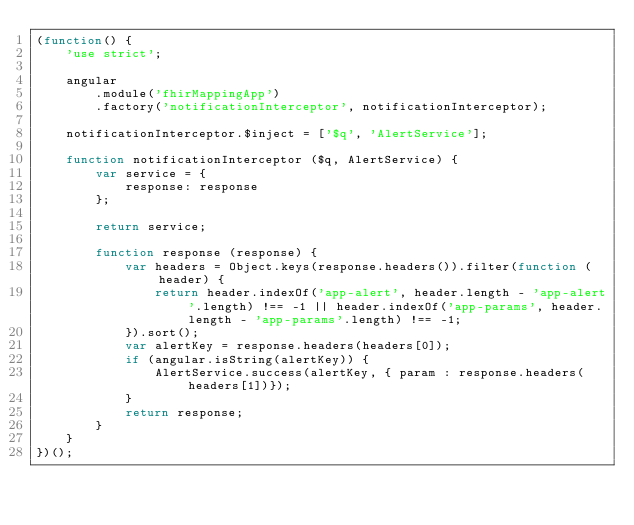Convert code to text. <code><loc_0><loc_0><loc_500><loc_500><_JavaScript_>(function() {
    'use strict';

    angular
        .module('fhirMappingApp')
        .factory('notificationInterceptor', notificationInterceptor);

    notificationInterceptor.$inject = ['$q', 'AlertService'];

    function notificationInterceptor ($q, AlertService) {
        var service = {
            response: response
        };

        return service;

        function response (response) {
            var headers = Object.keys(response.headers()).filter(function (header) {
                return header.indexOf('app-alert', header.length - 'app-alert'.length) !== -1 || header.indexOf('app-params', header.length - 'app-params'.length) !== -1;
            }).sort();
            var alertKey = response.headers(headers[0]);
            if (angular.isString(alertKey)) {
                AlertService.success(alertKey, { param : response.headers(headers[1])});
            }
            return response;
        }
    }
})();
</code> 